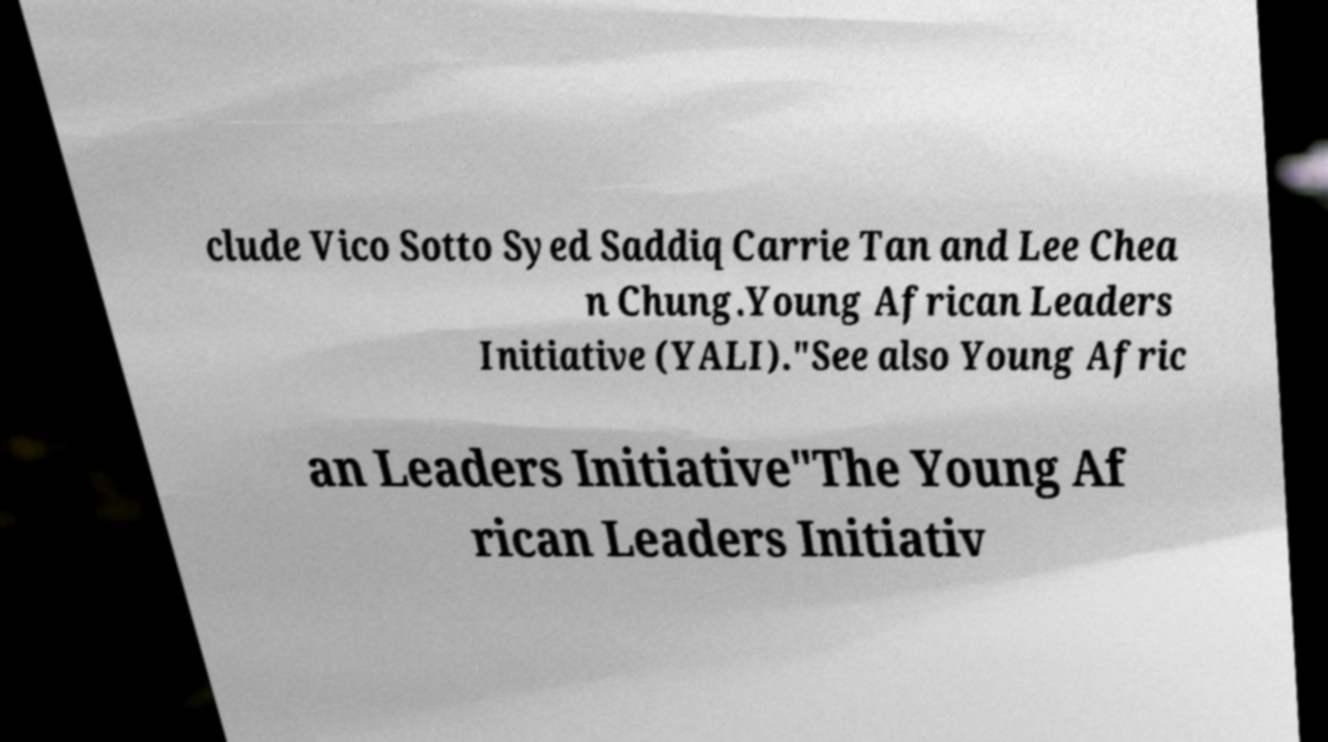Could you assist in decoding the text presented in this image and type it out clearly? clude Vico Sotto Syed Saddiq Carrie Tan and Lee Chea n Chung.Young African Leaders Initiative (YALI)."See also Young Afric an Leaders Initiative"The Young Af rican Leaders Initiativ 